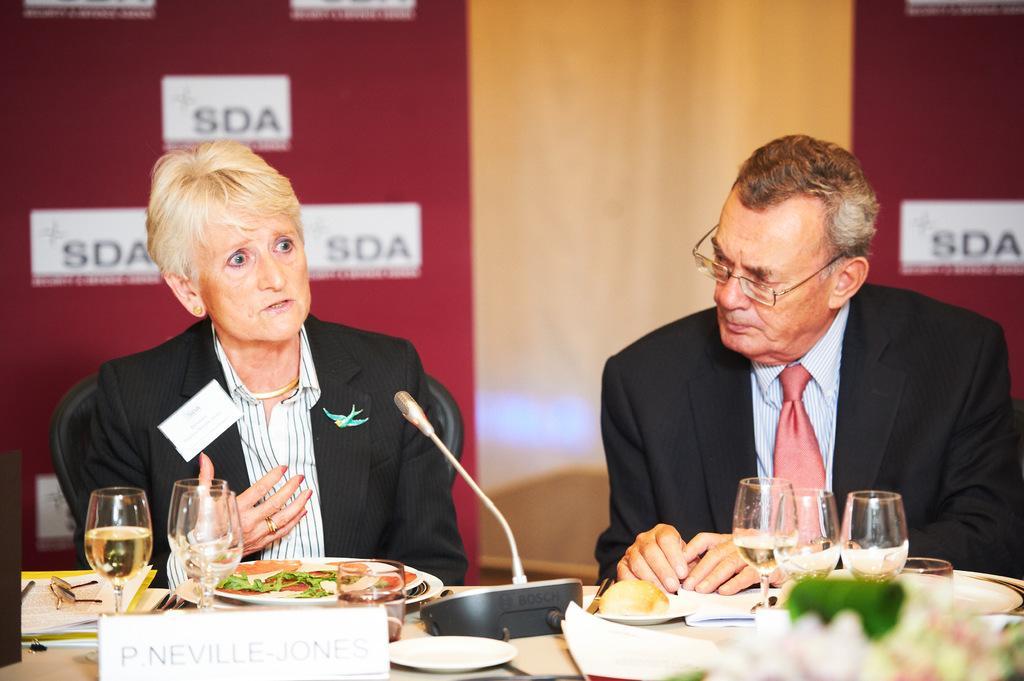Describe this image in one or two sentences. To the left side there is a lady with black jacket and white shirt is sitting on the chair. In front of her there is a mic. Beside her there is a man with black jacket, blue shirt and red tie is sitting. In front of them there is a table with the six glasses to the both corners of the table. In front of her there is a plate with food item in it, A name board and to the left corner of the table there are some files, papers and spectacles on it. In the background there is a poster. 